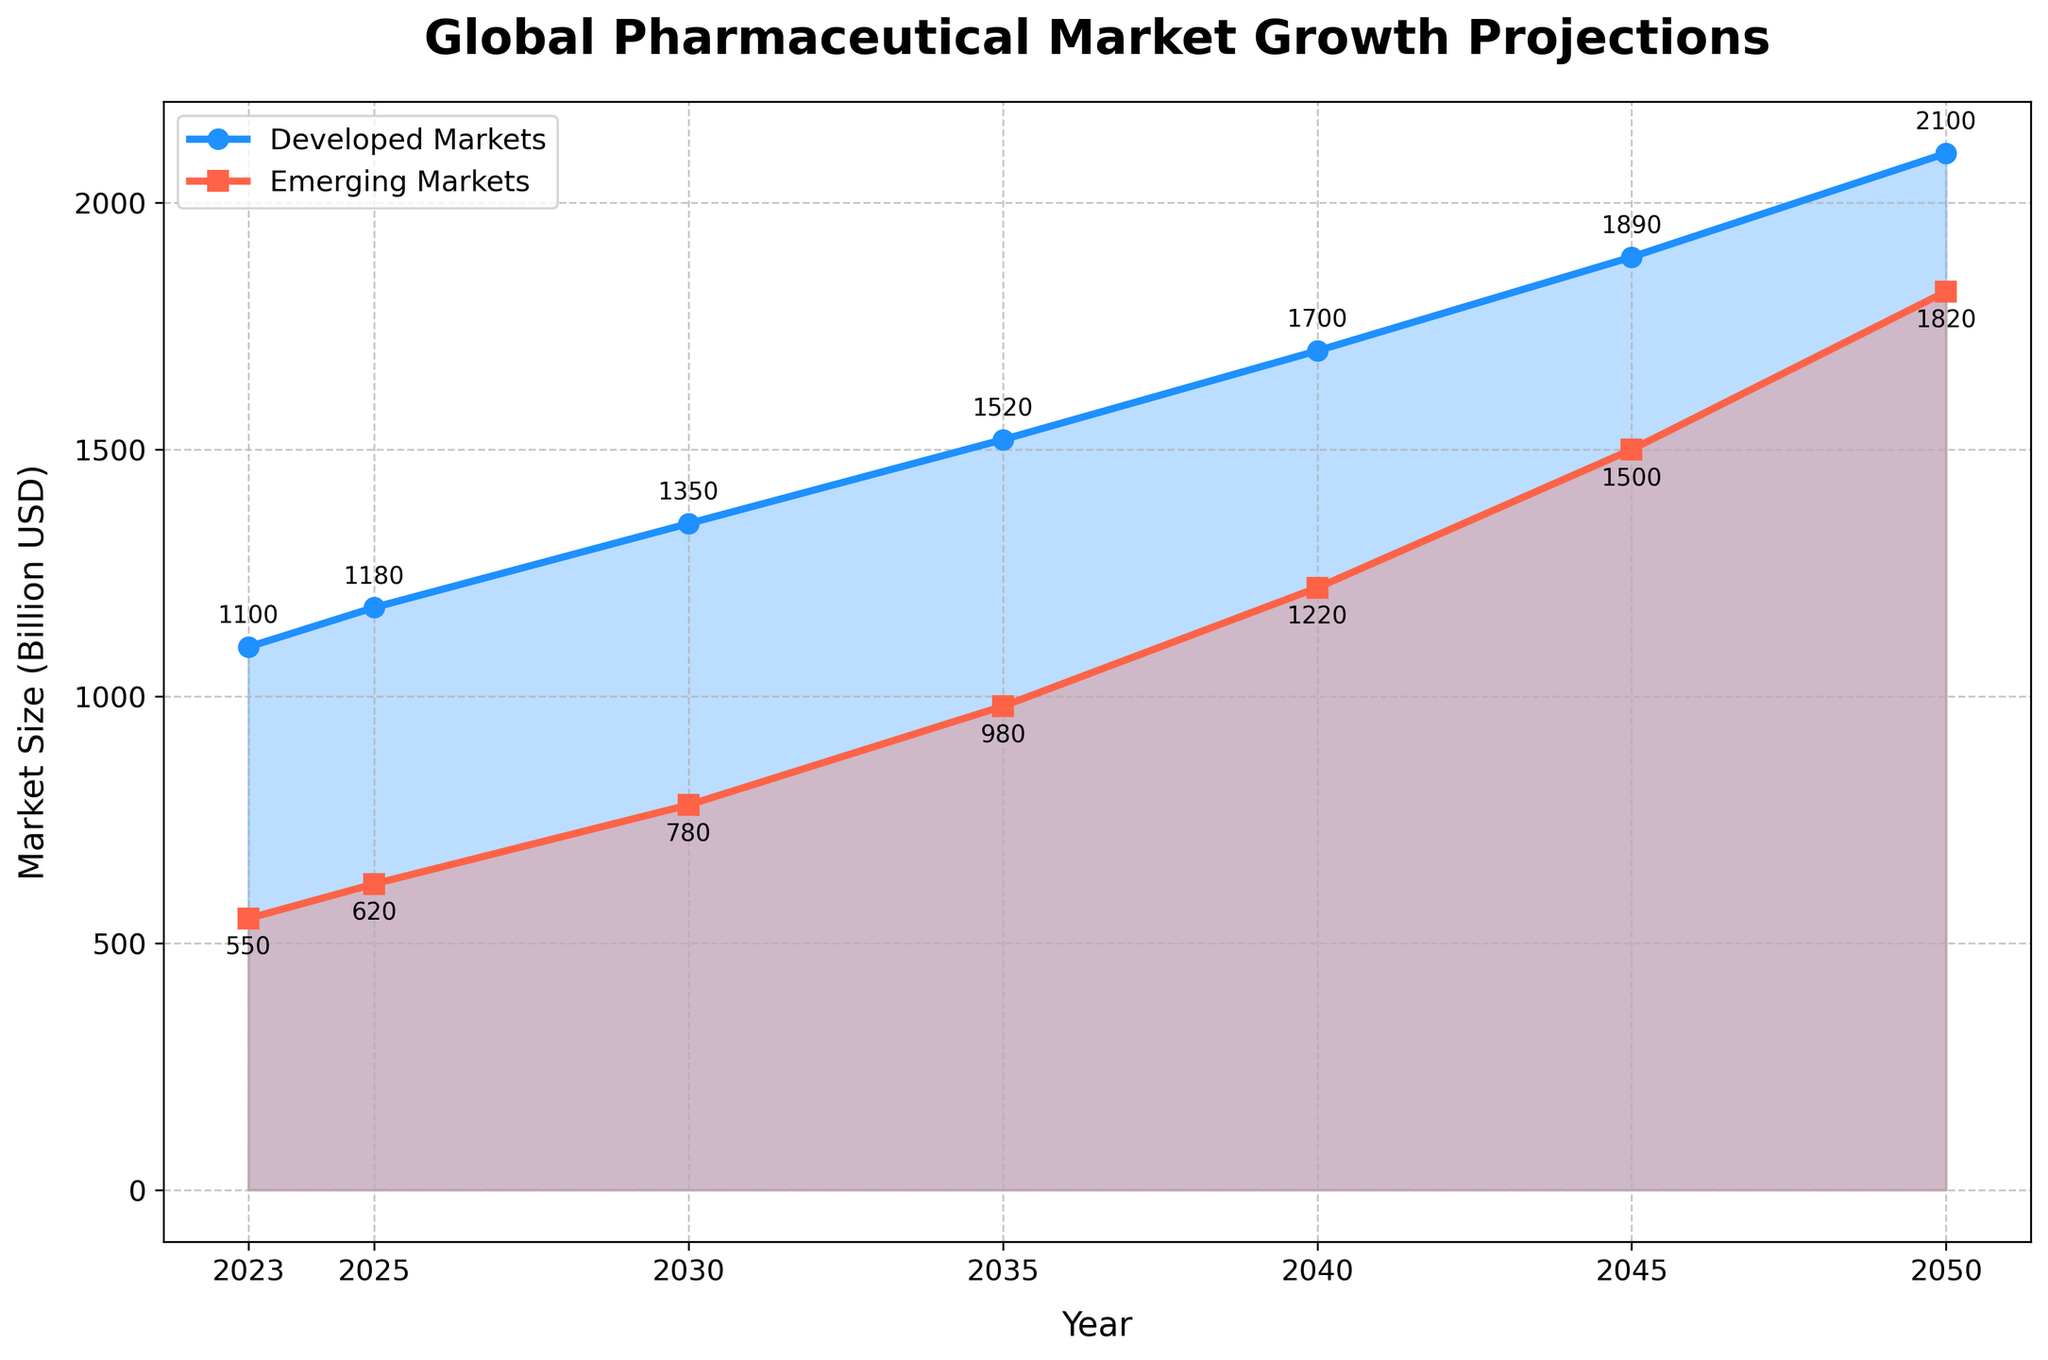What's the projected market size for Developed Markets in 2035? Refer to the value plotted for Developed Markets for the year 2035 on the line chart. The value marked is 1520 billion USD.
Answer: 1520 billion USD Which market, Developed or Emerging, shows a higher growth rate between 2023 and 2050? Calculate the growth for each market. Developed Markets: 2100 - 1100 = 1000 billion USD. Emerging Markets: 1820 - 550 = 1270 billion USD. Emerging Markets have a higher absolute growth.
Answer: Emerging Markets Compare the market sizes of Developed and Emerging Markets in 2040. By how much do the developed markets exceed the emerging ones in that year? Check the values at 2040 on both lines; Developed Markets = 1700 billion USD, Emerging Markets = 1220 billion USD. Calculate the difference: 1700 - 1220 = 480 billion USD.
Answer: 480 billion USD What is the average projected market size of Emerging Markets between 2023 and 2050? Sum the values for Emerging Markets over the years: 550 + 620 + 780 + 980 + 1220 + 1500 + 1820 = 7470. The average is 7470/7 ≈ 1067.14 billion USD.
Answer: 1067.14 billion USD In which year is the difference between Developed and Emerging Markets the smallest? Calculate the difference for each year:
2023: 1100 - 550 = 550
2025: 1180 - 620 = 560
2030: 1350 - 780 = 570
2035: 1520 - 980 = 540
2040: 1700 - 1220 = 480
2045: 1890 - 1500 = 390
2050: 2100 - 1820 = 280
The smallest difference is in 2050.
Answer: 2050 By how much does the Developed Markets' projected market size grow from 2025 to 2050? Subtract the Developed Markets' value in 2025 from the value in 2050: 2100 - 1180 = 920 billion USD.
Answer: 920 billion USD What visual markers are used to differentiate between Developed and Emerging Markets on the plot? The Developed Markets are marked with circles and a blue line, while Emerging Markets are marked with squares and a red line.
Answer: Circles (blue) for Developed, Squares (red) for Emerging By looking at the filled regions, which market shows a relatively steeper increase visualized on the y-axis between 2030 and 2040? Observe the slope of the filled region between 2030 and 2040. The Emerging Markets (red filled area) display a steeper rise.
Answer: Emerging Markets 